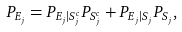<formula> <loc_0><loc_0><loc_500><loc_500>P _ { E _ { j } } & = P _ { E _ { j } | S _ { j } ^ { c } } P _ { S _ { j } ^ { c } } + P _ { E _ { j } | S _ { j } } P _ { S _ { j } } ,</formula> 